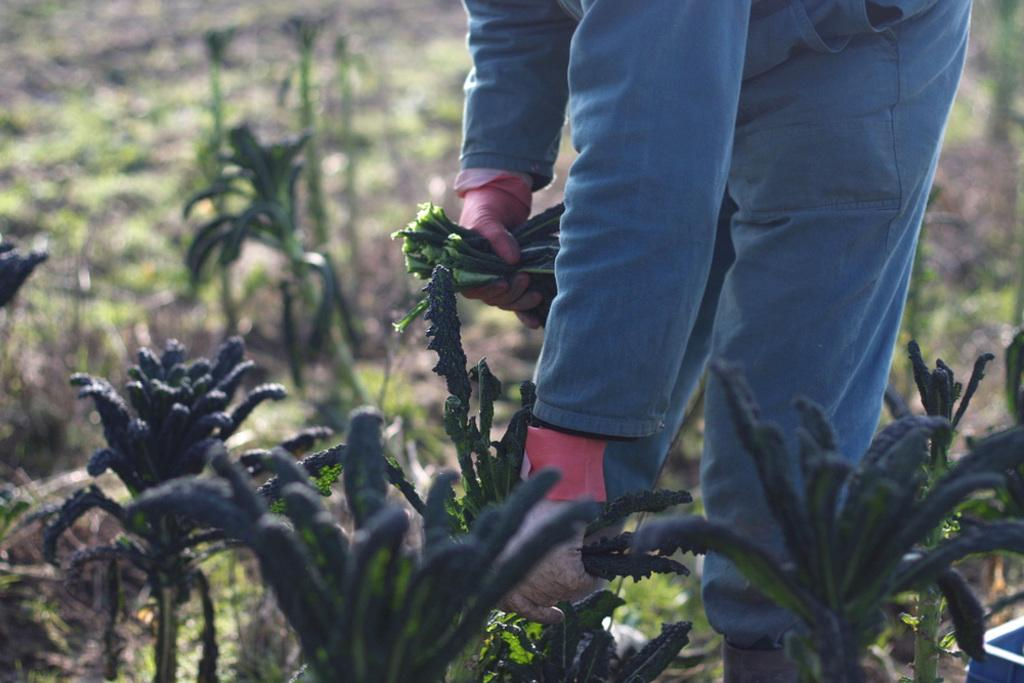Who is present in the image? There is a person in the image. What is the person doing in the image? The person is picking leaves from plants. What type of hat is the person wearing in the image? There is no hat visible in the image; the person is picking leaves from plants. 